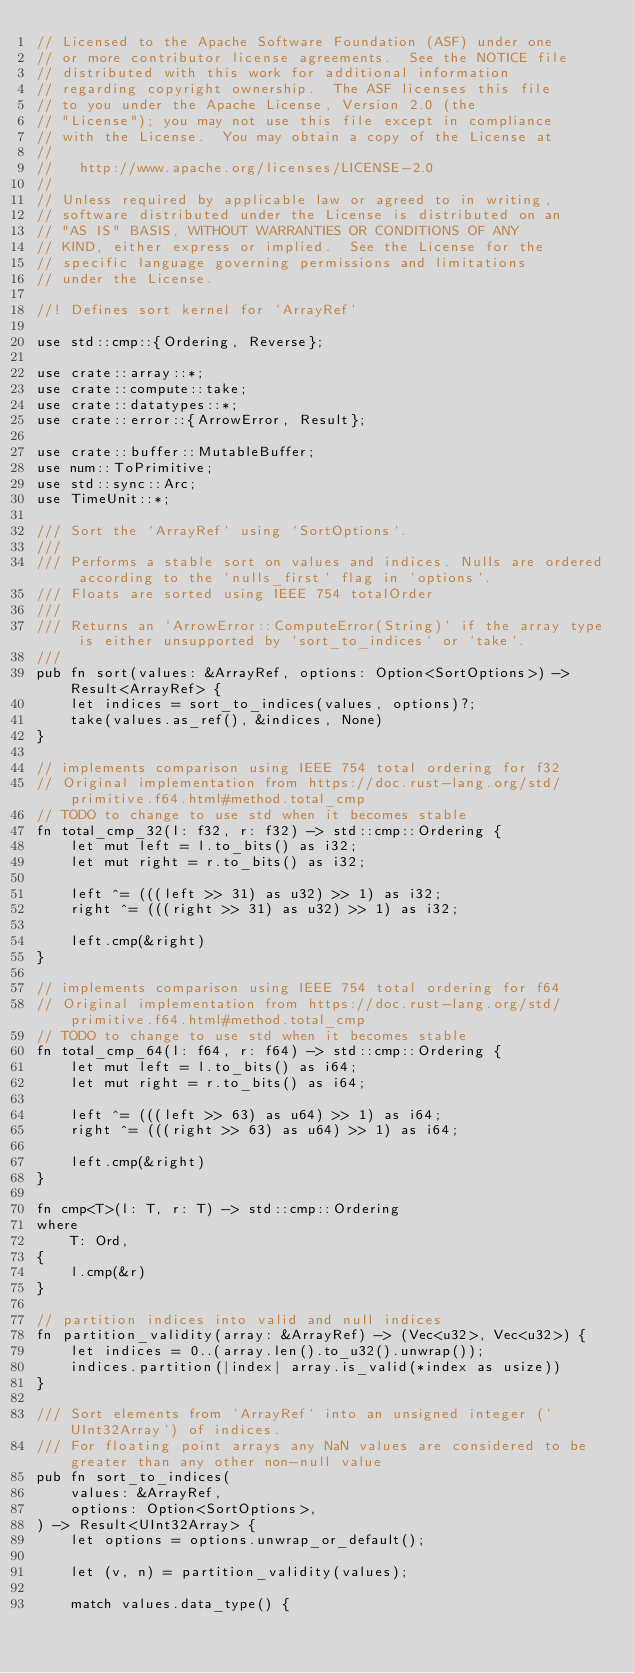Convert code to text. <code><loc_0><loc_0><loc_500><loc_500><_Rust_>// Licensed to the Apache Software Foundation (ASF) under one
// or more contributor license agreements.  See the NOTICE file
// distributed with this work for additional information
// regarding copyright ownership.  The ASF licenses this file
// to you under the Apache License, Version 2.0 (the
// "License"); you may not use this file except in compliance
// with the License.  You may obtain a copy of the License at
//
//   http://www.apache.org/licenses/LICENSE-2.0
//
// Unless required by applicable law or agreed to in writing,
// software distributed under the License is distributed on an
// "AS IS" BASIS, WITHOUT WARRANTIES OR CONDITIONS OF ANY
// KIND, either express or implied.  See the License for the
// specific language governing permissions and limitations
// under the License.

//! Defines sort kernel for `ArrayRef`

use std::cmp::{Ordering, Reverse};

use crate::array::*;
use crate::compute::take;
use crate::datatypes::*;
use crate::error::{ArrowError, Result};

use crate::buffer::MutableBuffer;
use num::ToPrimitive;
use std::sync::Arc;
use TimeUnit::*;

/// Sort the `ArrayRef` using `SortOptions`.
///
/// Performs a stable sort on values and indices. Nulls are ordered according to the `nulls_first` flag in `options`.
/// Floats are sorted using IEEE 754 totalOrder
///
/// Returns an `ArrowError::ComputeError(String)` if the array type is either unsupported by `sort_to_indices` or `take`.
///
pub fn sort(values: &ArrayRef, options: Option<SortOptions>) -> Result<ArrayRef> {
    let indices = sort_to_indices(values, options)?;
    take(values.as_ref(), &indices, None)
}

// implements comparison using IEEE 754 total ordering for f32
// Original implementation from https://doc.rust-lang.org/std/primitive.f64.html#method.total_cmp
// TODO to change to use std when it becomes stable
fn total_cmp_32(l: f32, r: f32) -> std::cmp::Ordering {
    let mut left = l.to_bits() as i32;
    let mut right = r.to_bits() as i32;

    left ^= (((left >> 31) as u32) >> 1) as i32;
    right ^= (((right >> 31) as u32) >> 1) as i32;

    left.cmp(&right)
}

// implements comparison using IEEE 754 total ordering for f64
// Original implementation from https://doc.rust-lang.org/std/primitive.f64.html#method.total_cmp
// TODO to change to use std when it becomes stable
fn total_cmp_64(l: f64, r: f64) -> std::cmp::Ordering {
    let mut left = l.to_bits() as i64;
    let mut right = r.to_bits() as i64;

    left ^= (((left >> 63) as u64) >> 1) as i64;
    right ^= (((right >> 63) as u64) >> 1) as i64;

    left.cmp(&right)
}

fn cmp<T>(l: T, r: T) -> std::cmp::Ordering
where
    T: Ord,
{
    l.cmp(&r)
}

// partition indices into valid and null indices
fn partition_validity(array: &ArrayRef) -> (Vec<u32>, Vec<u32>) {
    let indices = 0..(array.len().to_u32().unwrap());
    indices.partition(|index| array.is_valid(*index as usize))
}

/// Sort elements from `ArrayRef` into an unsigned integer (`UInt32Array`) of indices.
/// For floating point arrays any NaN values are considered to be greater than any other non-null value
pub fn sort_to_indices(
    values: &ArrayRef,
    options: Option<SortOptions>,
) -> Result<UInt32Array> {
    let options = options.unwrap_or_default();

    let (v, n) = partition_validity(values);

    match values.data_type() {</code> 